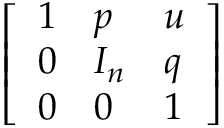Convert formula to latex. <formula><loc_0><loc_0><loc_500><loc_500>\left [ \begin{array} { l l l } { 1 } & { p } & { u } \\ { 0 } & { I _ { n } } & { q } \\ { 0 } & { 0 } & { 1 } \end{array} \right ]</formula> 